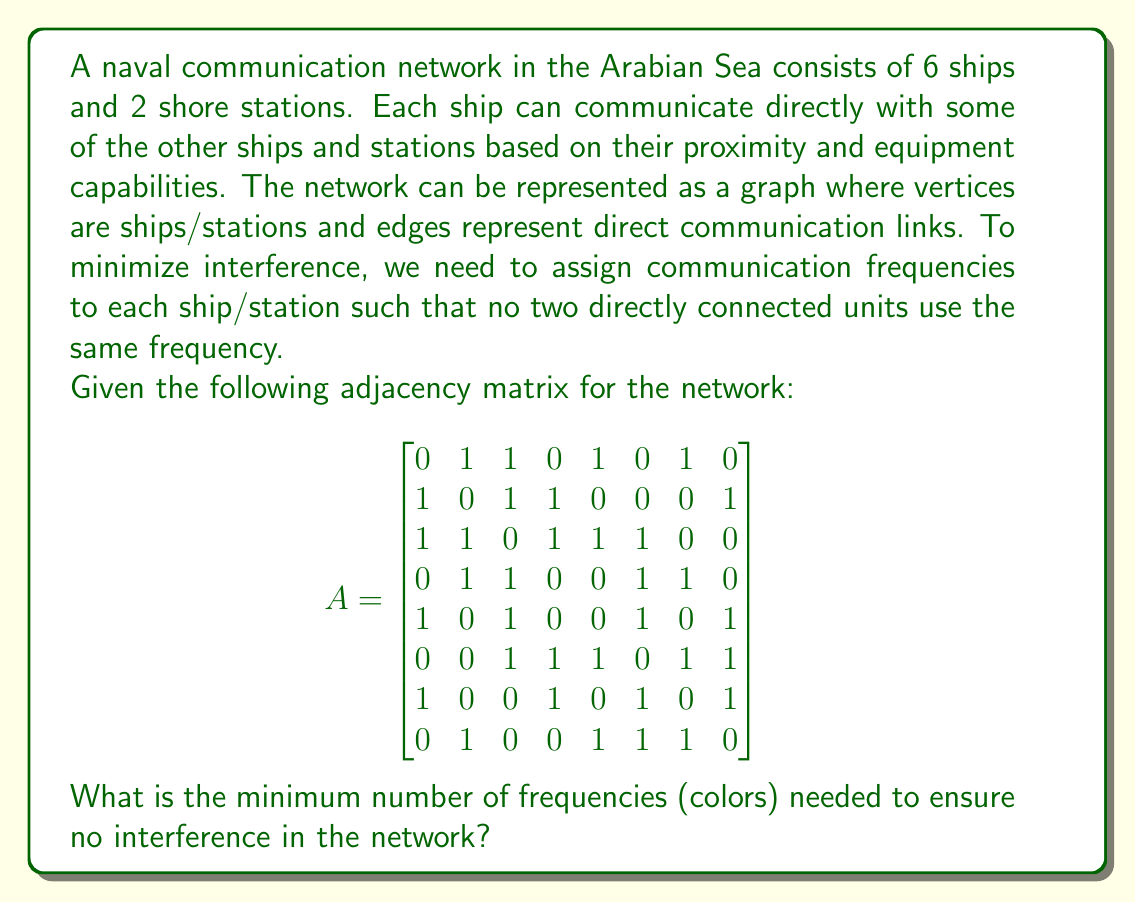Show me your answer to this math problem. To solve this problem, we need to determine the chromatic number of the graph represented by the given adjacency matrix. The chromatic number is the minimum number of colors needed to color the vertices of a graph such that no two adjacent vertices have the same color.

Let's approach this step-by-step:

1. First, we need to visualize the graph. While we can't draw it here, we can analyze the adjacency matrix to understand the connections.

2. We'll use the Welsh-Powell algorithm to find an upper bound for the chromatic number:

   a. Order the vertices by descending degree:
      - Vertex 3 (degree 5)
      - Vertices 2, 6, 8 (degree 4)
      - Vertices 1, 4, 5, 7 (degree 3)

   b. Assign colors:
      - Color 1: Vertex 3
      - Color 2: Vertices 1, 4, 8
      - Color 3: Vertices 2, 5, 7
      - Color 4: Vertex 6

3. This coloring uses 4 colors, so we know the chromatic number is at most 4.

4. To prove that 4 is indeed the minimum, we need to show that 3 colors are not sufficient:
   - The subgraph formed by vertices 2, 3, 4, and 6 is a complete graph (K4).
   - A complete graph with n vertices requires n colors.
   - Therefore, these 4 vertices alone require 4 colors.

5. Thus, we can conclude that the chromatic number of this graph is exactly 4.

This means that a minimum of 4 different frequencies are needed to ensure no interference in the naval communication network.
Answer: The minimum number of frequencies (colors) needed is 4. 